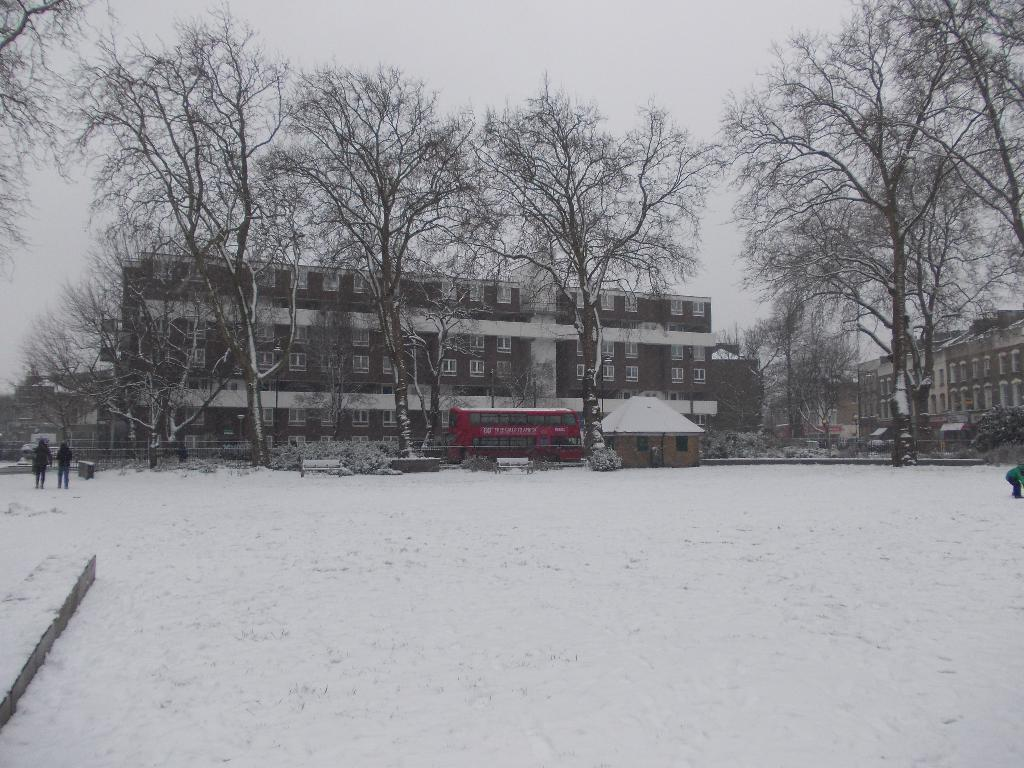What is the setting of the image? The people are on snow in the image. What type of seating can be seen in the image? There are benches in the image. What type of structures are present in the image? There are buildings with windows in the image. What type of vegetation is present in the image? There are trees in the image. What type of transportation is visible in the image? There is a bus in the image. What type of residential structure is present in the image? There is a house in the image. What is visible in the background of the image? The sky is visible in the background of the image. What is the weight of the spade in the image? There is no text or spade present in the image, so it is not possible to determine the weight of a spade. How many bushes are visible in the image? There are no bushes visible in the image. 